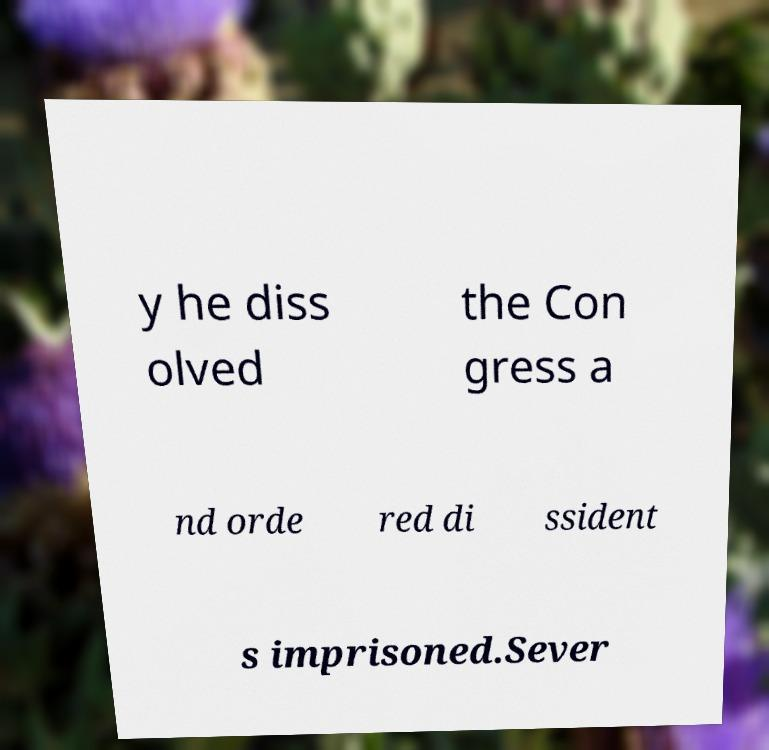There's text embedded in this image that I need extracted. Can you transcribe it verbatim? y he diss olved the Con gress a nd orde red di ssident s imprisoned.Sever 